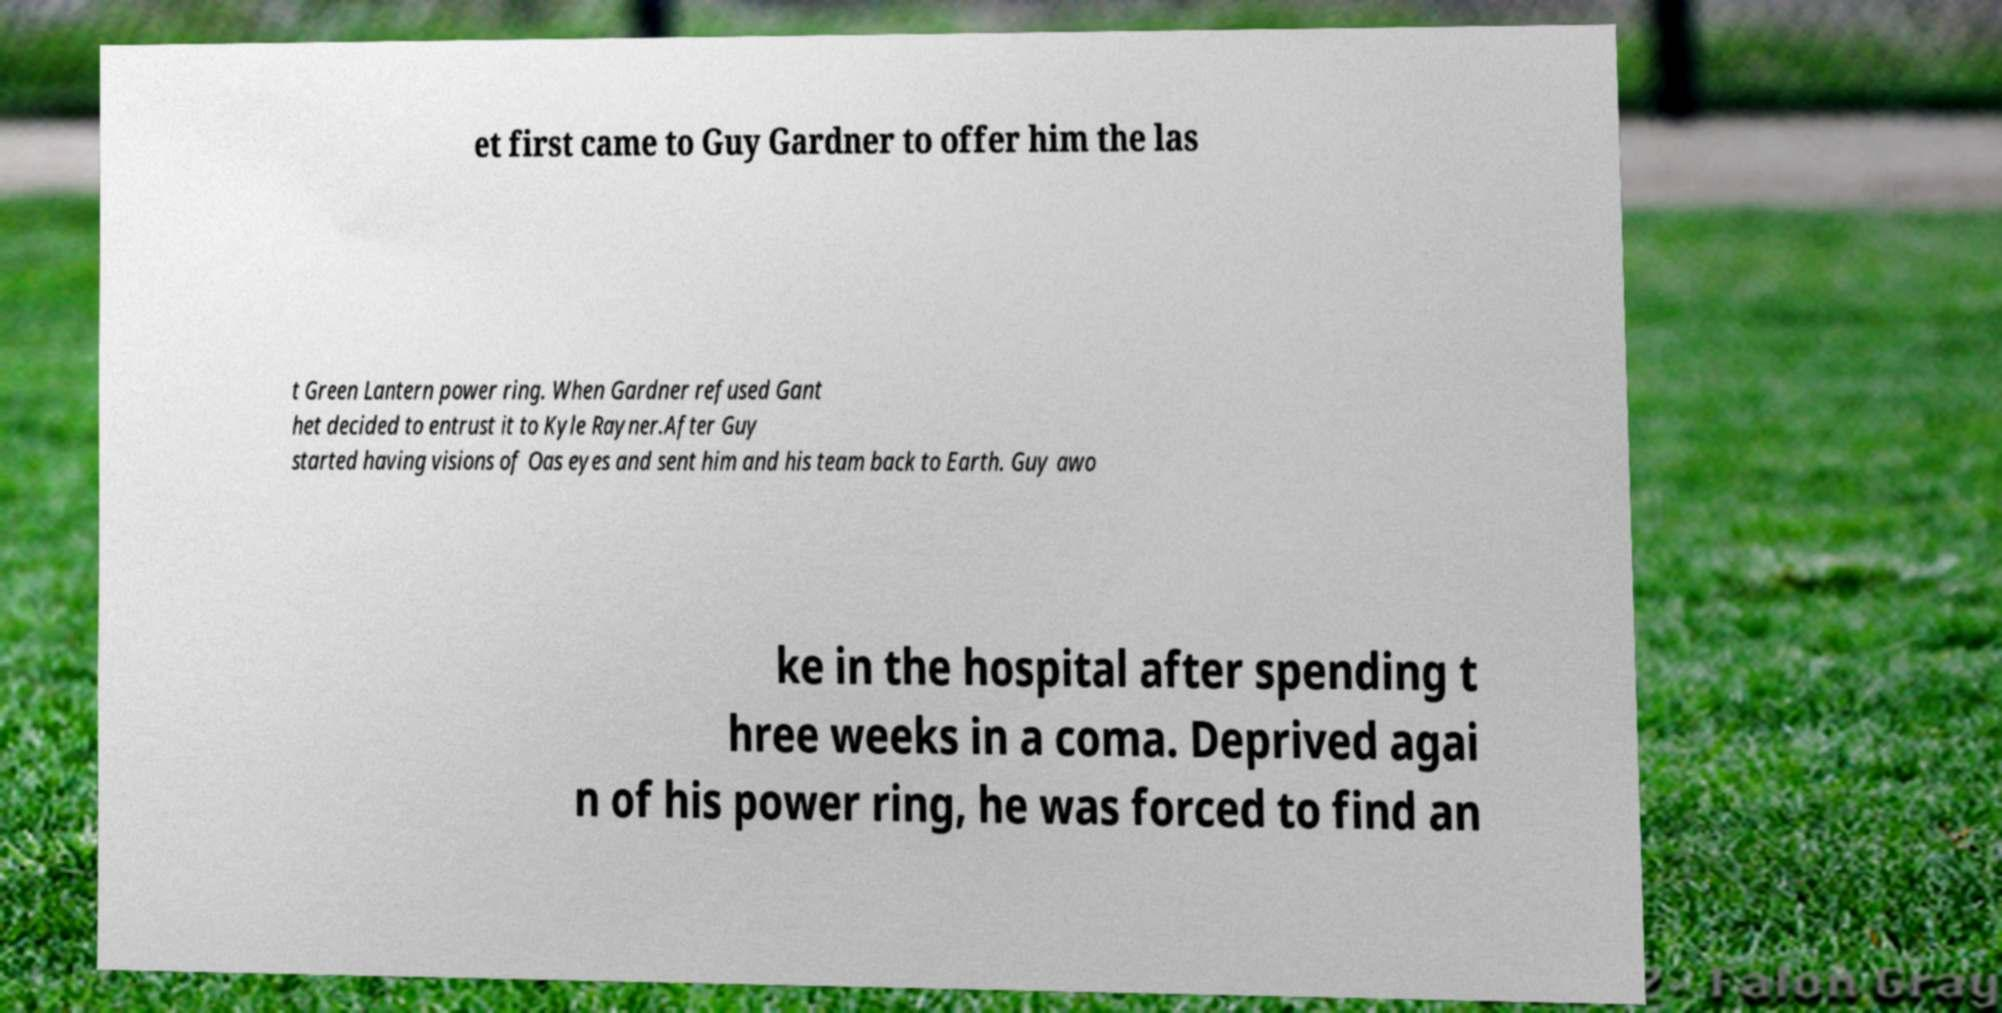Could you extract and type out the text from this image? et first came to Guy Gardner to offer him the las t Green Lantern power ring. When Gardner refused Gant het decided to entrust it to Kyle Rayner.After Guy started having visions of Oas eyes and sent him and his team back to Earth. Guy awo ke in the hospital after spending t hree weeks in a coma. Deprived agai n of his power ring, he was forced to find an 